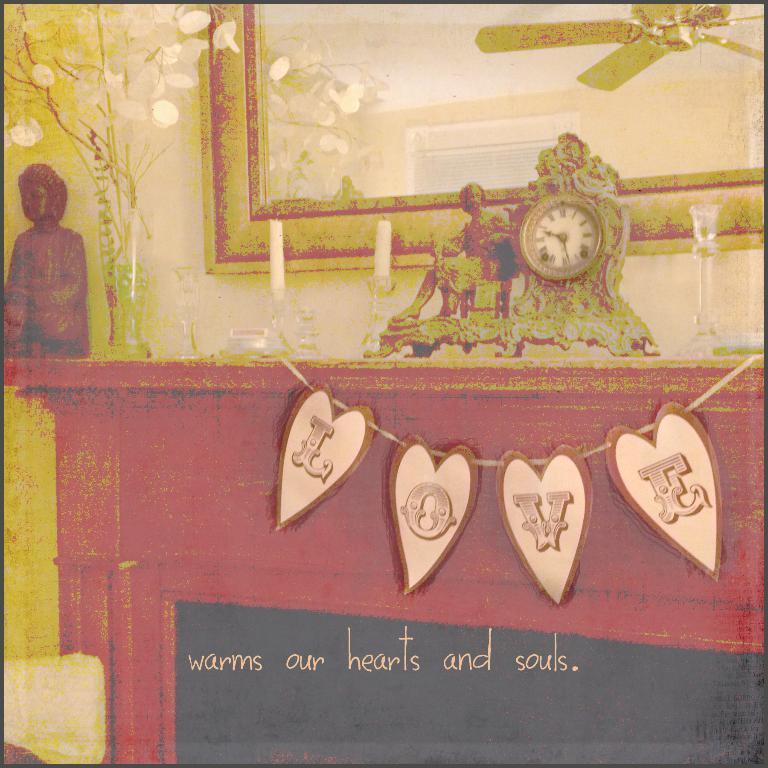What word is spelled out in the banner?
Make the answer very short. Love. What phrase is written on in black area of fireplace?
Your answer should be very brief. Warms our hearts and souls. 